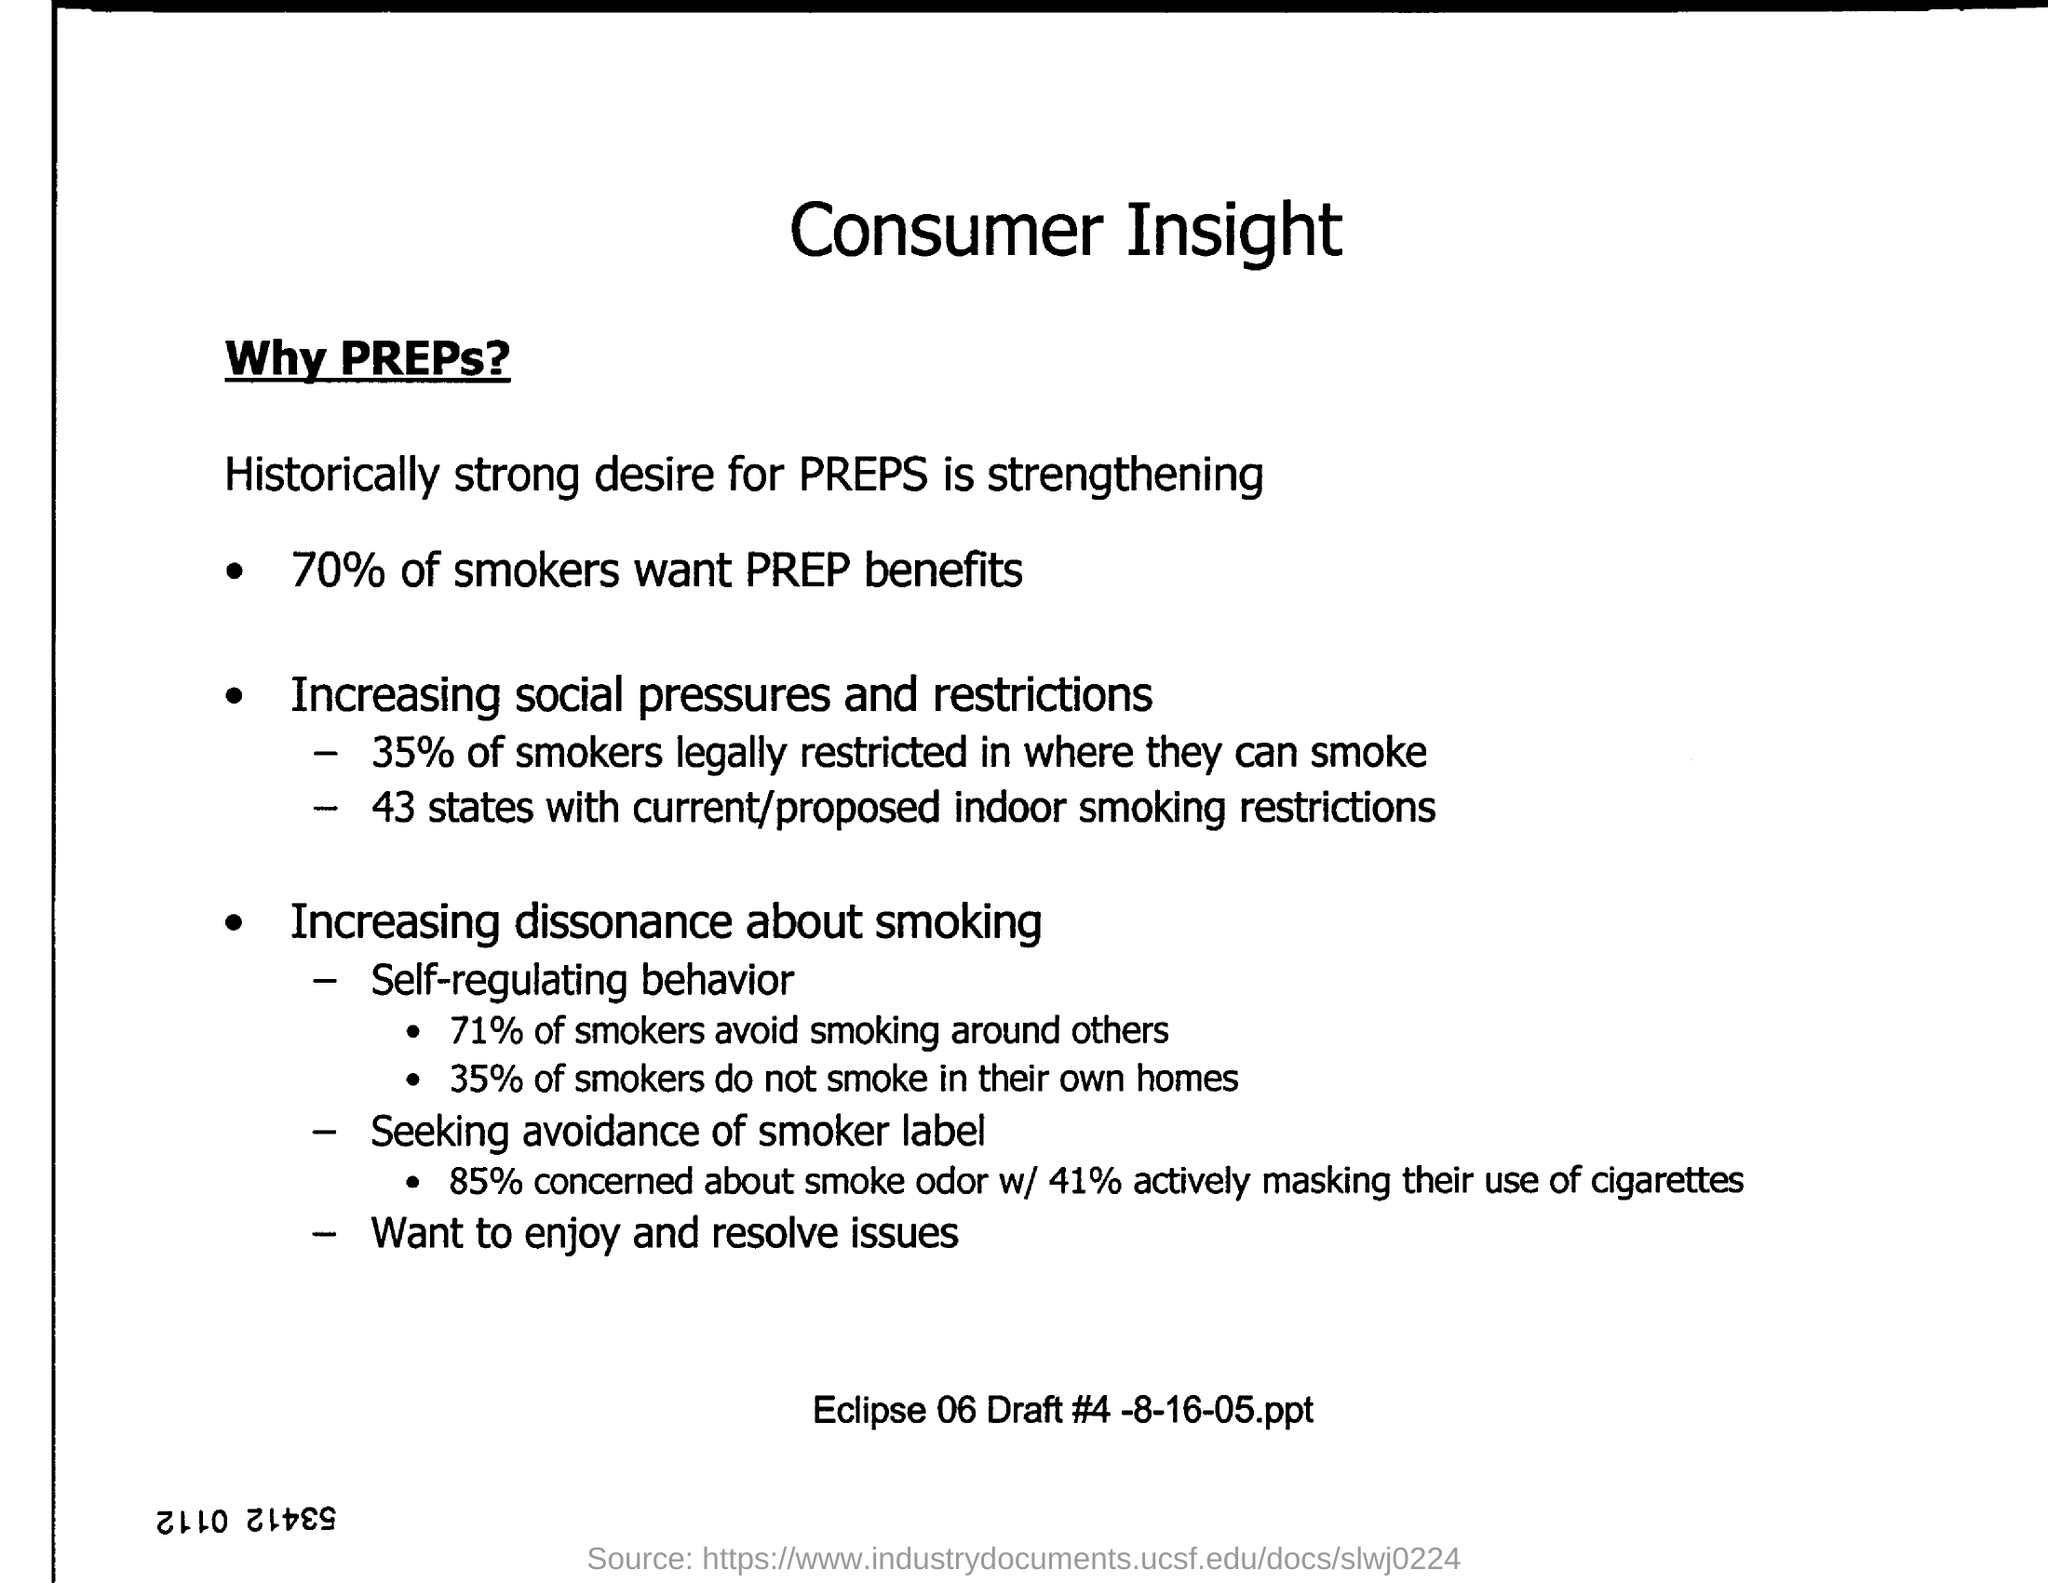What percentage of smokers desire the benefits of PREPs (Potentially Reduced Exposure Products)? Based on the image, 70% of smokers are interested in the benefits offered by Potentially Reduced Exposure Products (PREPs), which indicates a strong desire among smokers for alternatives that may reduce health risks. 